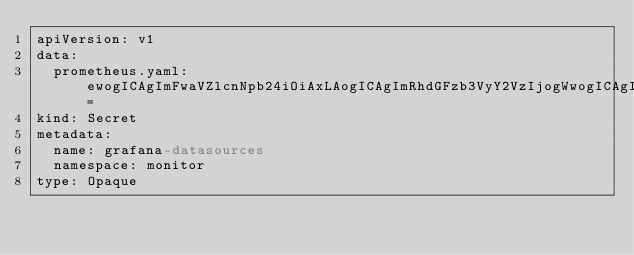Convert code to text. <code><loc_0><loc_0><loc_500><loc_500><_YAML_>apiVersion: v1
data:
  prometheus.yaml: ewogICAgImFwaVZlcnNpb24iOiAxLAogICAgImRhdGFzb3VyY2VzIjogWwogICAgICAgIHsKICAgICAgICAgICAgImFjY2VzcyI6ICJwcm94eSIsCiAgICAgICAgICAgICJlZGl0YWJsZSI6IGZhbHNlLAogICAgICAgICAgICAibmFtZSI6ICJwcm9tZXRoZXVzIiwKICAgICAgICAgICAgIm9yZ0lkIjogMSwKICAgICAgICAgICAgInR5cGUiOiAicHJvbWV0aGV1cyIsCiAgICAgICAgICAgICJ1cmwiOiAiaHR0cDovL3Byb21ldGhldXMtazhzLm1vbml0b3Iuc3ZjOjkwOTAiLAogICAgICAgICAgICAidmVyc2lvbiI6IDEKICAgICAgICB9CiAgICBdCn0=
kind: Secret
metadata:
  name: grafana-datasources
  namespace: monitor
type: Opaque
</code> 